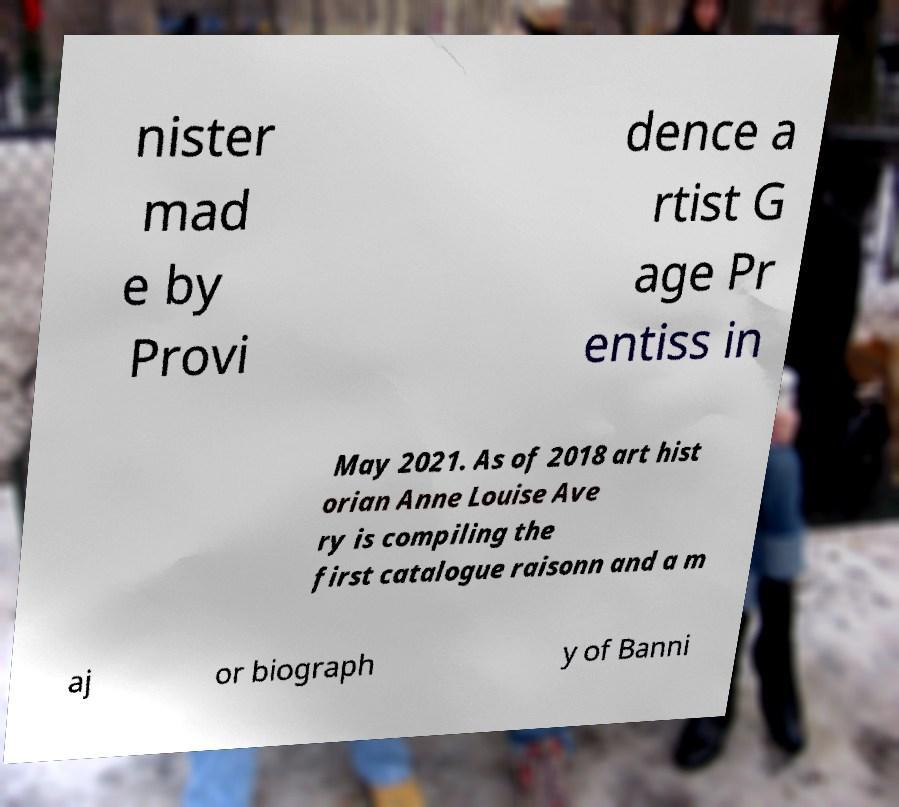Could you assist in decoding the text presented in this image and type it out clearly? nister mad e by Provi dence a rtist G age Pr entiss in May 2021. As of 2018 art hist orian Anne Louise Ave ry is compiling the first catalogue raisonn and a m aj or biograph y of Banni 